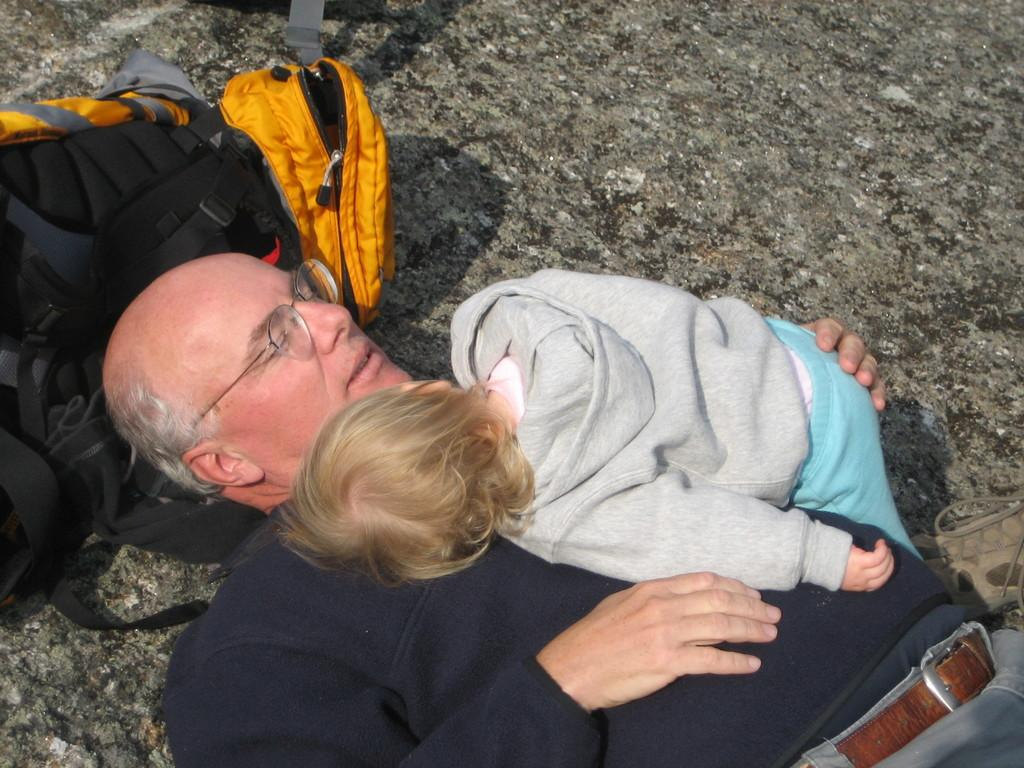Who is the main subject in the image? There is an old man in the image. What is the old man doing in the image? The old man is lying on the ground and holding a baby. What accessory is the old man wearing? The old man is wearing glasses. What object is near the old man's head? There is a bag near the old man's head. What type of collar can be seen on the lamp in the image? There is no lamp or collar present in the image. How much credit does the old man have in the image? There is no mention of credit or financial transactions in the image. 